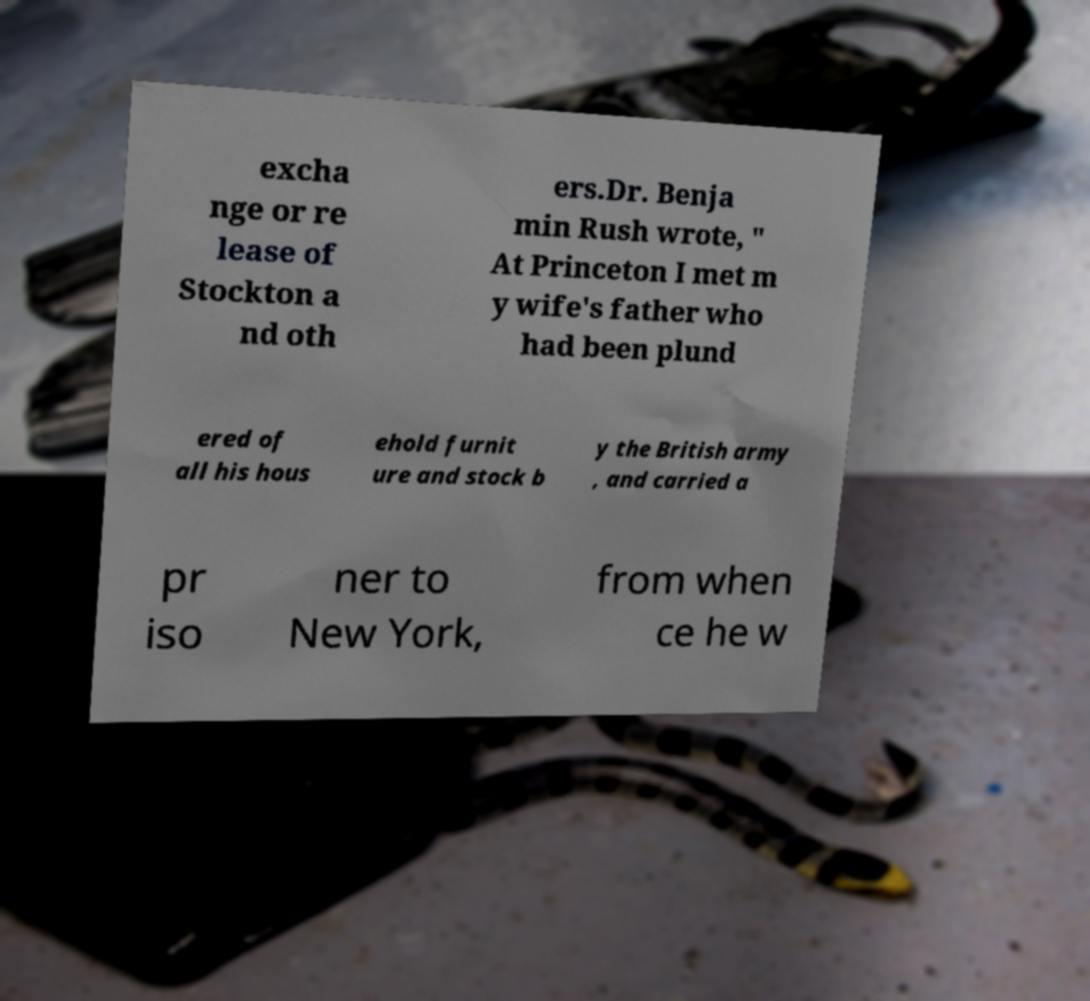Can you read and provide the text displayed in the image?This photo seems to have some interesting text. Can you extract and type it out for me? excha nge or re lease of Stockton a nd oth ers.Dr. Benja min Rush wrote, " At Princeton I met m y wife's father who had been plund ered of all his hous ehold furnit ure and stock b y the British army , and carried a pr iso ner to New York, from when ce he w 